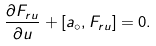Convert formula to latex. <formula><loc_0><loc_0><loc_500><loc_500>\frac { \partial F _ { r u } } { \partial u } + [ a _ { \circ } , F _ { r u } ] = 0 .</formula> 